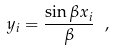Convert formula to latex. <formula><loc_0><loc_0><loc_500><loc_500>y _ { i } = \frac { \sin \beta x _ { i } } { \beta } \ ,</formula> 